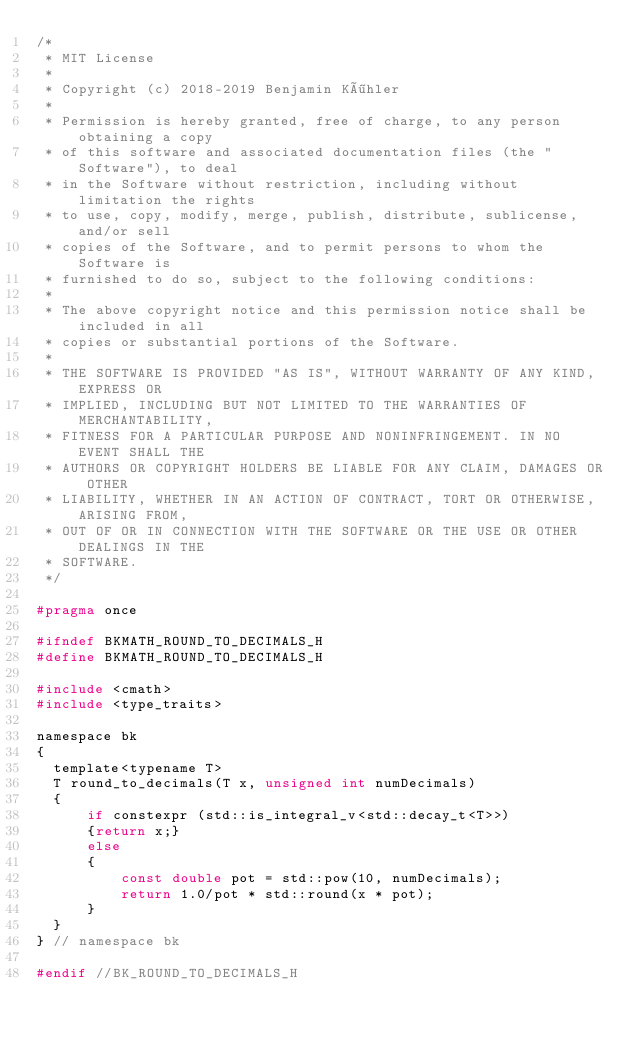<code> <loc_0><loc_0><loc_500><loc_500><_C_>/*
 * MIT License
 *
 * Copyright (c) 2018-2019 Benjamin Köhler
 *
 * Permission is hereby granted, free of charge, to any person obtaining a copy
 * of this software and associated documentation files (the "Software"), to deal
 * in the Software without restriction, including without limitation the rights
 * to use, copy, modify, merge, publish, distribute, sublicense, and/or sell
 * copies of the Software, and to permit persons to whom the Software is
 * furnished to do so, subject to the following conditions:
 *
 * The above copyright notice and this permission notice shall be included in all
 * copies or substantial portions of the Software.
 *
 * THE SOFTWARE IS PROVIDED "AS IS", WITHOUT WARRANTY OF ANY KIND, EXPRESS OR
 * IMPLIED, INCLUDING BUT NOT LIMITED TO THE WARRANTIES OF MERCHANTABILITY,
 * FITNESS FOR A PARTICULAR PURPOSE AND NONINFRINGEMENT. IN NO EVENT SHALL THE
 * AUTHORS OR COPYRIGHT HOLDERS BE LIABLE FOR ANY CLAIM, DAMAGES OR OTHER
 * LIABILITY, WHETHER IN AN ACTION OF CONTRACT, TORT OR OTHERWISE, ARISING FROM,
 * OUT OF OR IN CONNECTION WITH THE SOFTWARE OR THE USE OR OTHER DEALINGS IN THE
 * SOFTWARE.
 */

#pragma once

#ifndef BKMATH_ROUND_TO_DECIMALS_H
#define BKMATH_ROUND_TO_DECIMALS_H

#include <cmath>
#include <type_traits>

namespace bk
{
  template<typename T>
  T round_to_decimals(T x, unsigned int numDecimals)
  {
      if constexpr (std::is_integral_v<std::decay_t<T>>)
      {return x;}
      else
      {
          const double pot = std::pow(10, numDecimals);
          return 1.0/pot * std::round(x * pot);
      }
  }
} // namespace bk

#endif //BK_ROUND_TO_DECIMALS_H
</code> 